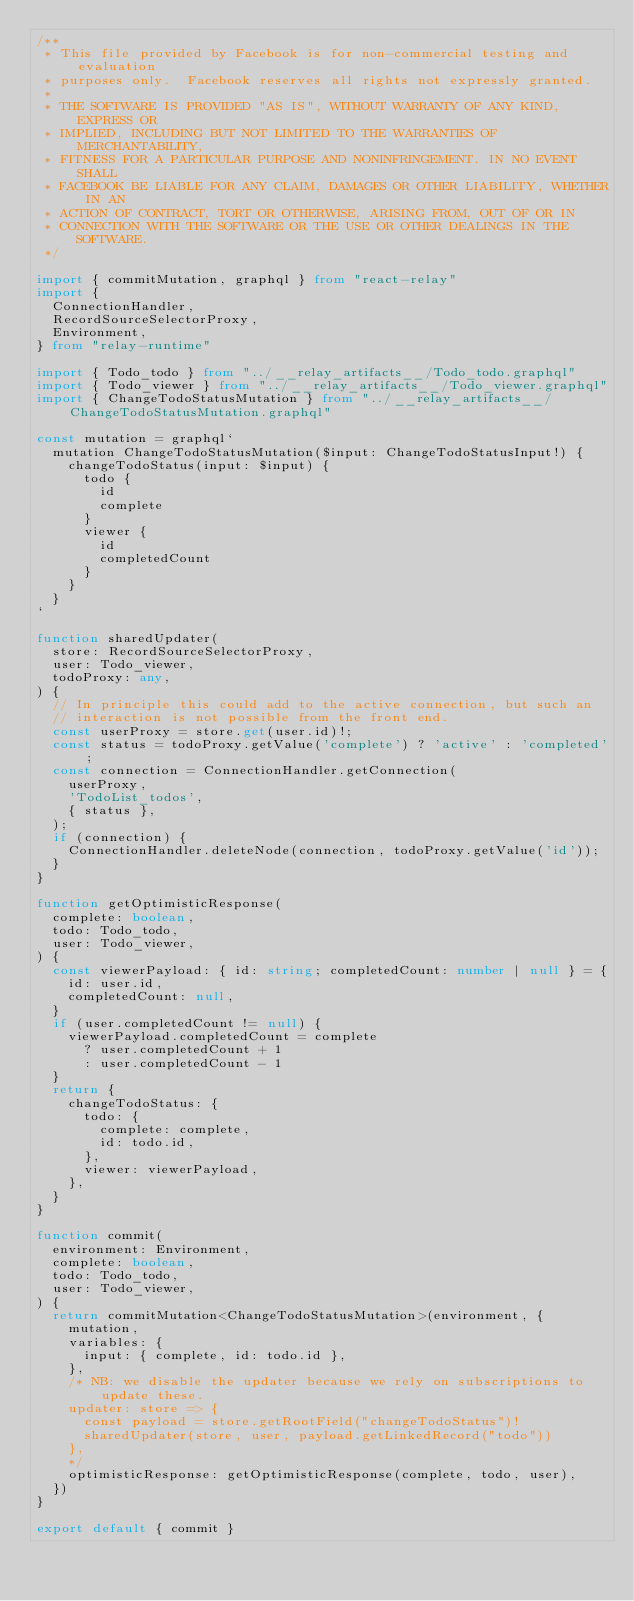<code> <loc_0><loc_0><loc_500><loc_500><_TypeScript_>/**
 * This file provided by Facebook is for non-commercial testing and evaluation
 * purposes only.  Facebook reserves all rights not expressly granted.
 *
 * THE SOFTWARE IS PROVIDED "AS IS", WITHOUT WARRANTY OF ANY KIND, EXPRESS OR
 * IMPLIED, INCLUDING BUT NOT LIMITED TO THE WARRANTIES OF MERCHANTABILITY,
 * FITNESS FOR A PARTICULAR PURPOSE AND NONINFRINGEMENT. IN NO EVENT SHALL
 * FACEBOOK BE LIABLE FOR ANY CLAIM, DAMAGES OR OTHER LIABILITY, WHETHER IN AN
 * ACTION OF CONTRACT, TORT OR OTHERWISE, ARISING FROM, OUT OF OR IN
 * CONNECTION WITH THE SOFTWARE OR THE USE OR OTHER DEALINGS IN THE SOFTWARE.
 */

import { commitMutation, graphql } from "react-relay"
import {
  ConnectionHandler,
  RecordSourceSelectorProxy,
  Environment,
} from "relay-runtime"

import { Todo_todo } from "../__relay_artifacts__/Todo_todo.graphql"
import { Todo_viewer } from "../__relay_artifacts__/Todo_viewer.graphql"
import { ChangeTodoStatusMutation } from "../__relay_artifacts__/ChangeTodoStatusMutation.graphql"

const mutation = graphql`
  mutation ChangeTodoStatusMutation($input: ChangeTodoStatusInput!) {
    changeTodoStatus(input: $input) {
      todo {
        id
        complete
      }
      viewer {
        id
        completedCount
      }
    }
  }
`

function sharedUpdater(
  store: RecordSourceSelectorProxy,
  user: Todo_viewer,
  todoProxy: any,
) {
  // In principle this could add to the active connection, but such an
  // interaction is not possible from the front end.
  const userProxy = store.get(user.id)!;
  const status = todoProxy.getValue('complete') ? 'active' : 'completed';
  const connection = ConnectionHandler.getConnection(
    userProxy,
    'TodoList_todos',
    { status },
  );
  if (connection) {
    ConnectionHandler.deleteNode(connection, todoProxy.getValue('id'));
  }
}

function getOptimisticResponse(
  complete: boolean,
  todo: Todo_todo,
  user: Todo_viewer,
) {
  const viewerPayload: { id: string; completedCount: number | null } = {
    id: user.id,
    completedCount: null,
  }
  if (user.completedCount != null) {
    viewerPayload.completedCount = complete
      ? user.completedCount + 1
      : user.completedCount - 1
  }
  return {
    changeTodoStatus: {
      todo: {
        complete: complete,
        id: todo.id,
      },
      viewer: viewerPayload,
    },
  }
}

function commit(
  environment: Environment,
  complete: boolean,
  todo: Todo_todo,
  user: Todo_viewer,
) {
  return commitMutation<ChangeTodoStatusMutation>(environment, {
    mutation,
    variables: {
      input: { complete, id: todo.id },
    },
    /* NB: we disable the updater because we rely on subscriptions to update these.
    updater: store => {
      const payload = store.getRootField("changeTodoStatus")!
      sharedUpdater(store, user, payload.getLinkedRecord("todo"))
    },
    */
    optimisticResponse: getOptimisticResponse(complete, todo, user),
  })
}

export default { commit }
</code> 